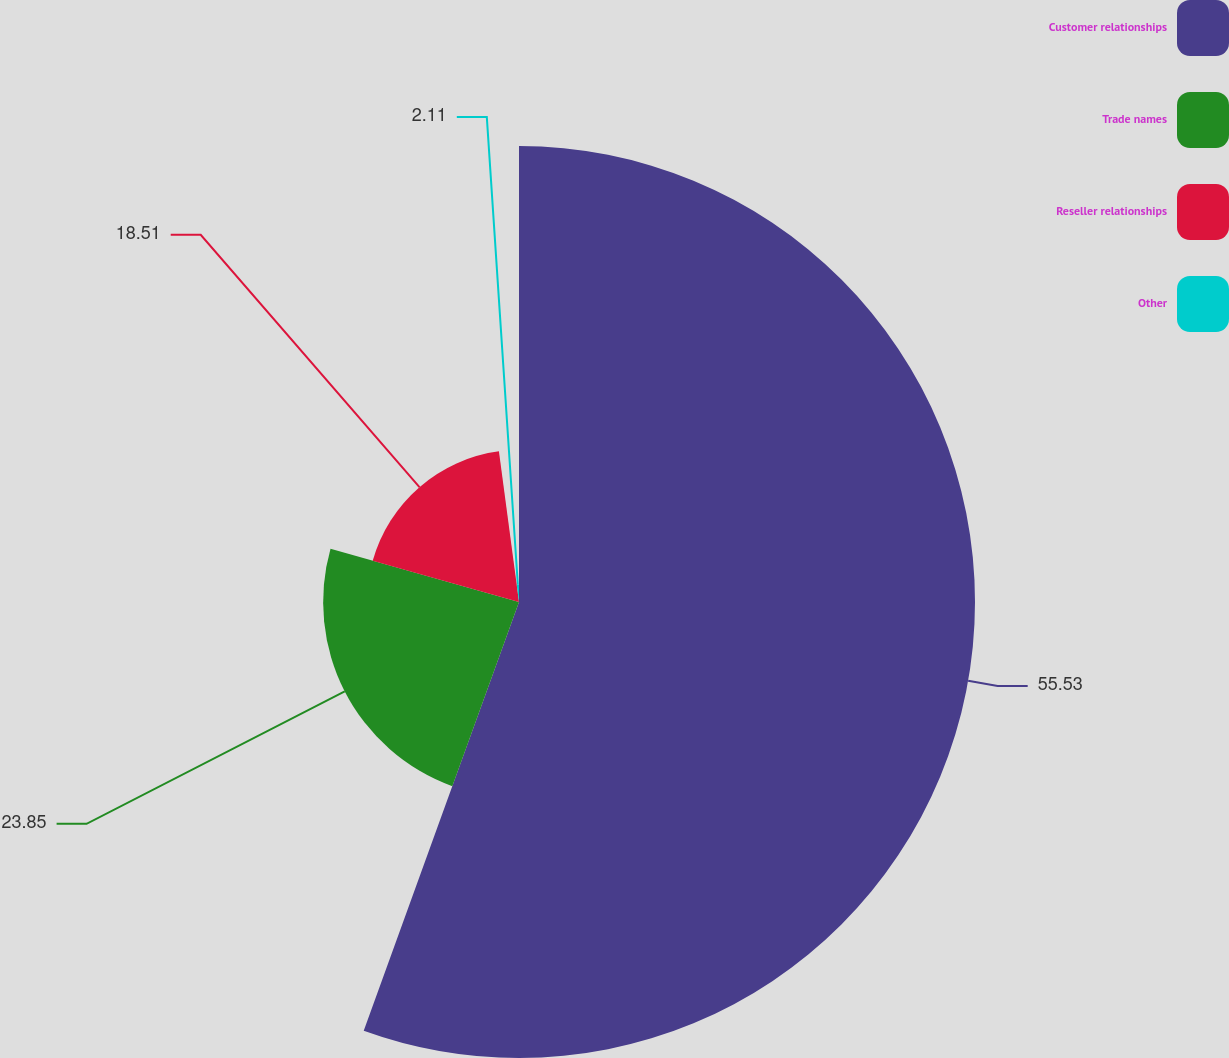<chart> <loc_0><loc_0><loc_500><loc_500><pie_chart><fcel>Customer relationships<fcel>Trade names<fcel>Reseller relationships<fcel>Other<nl><fcel>55.53%<fcel>23.85%<fcel>18.51%<fcel>2.11%<nl></chart> 